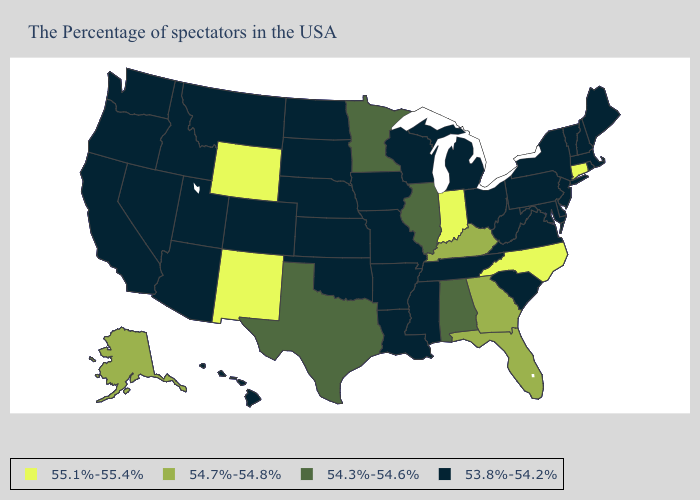What is the highest value in the USA?
Quick response, please. 55.1%-55.4%. What is the lowest value in the USA?
Answer briefly. 53.8%-54.2%. Name the states that have a value in the range 55.1%-55.4%?
Quick response, please. Connecticut, North Carolina, Indiana, Wyoming, New Mexico. Among the states that border Missouri , which have the highest value?
Write a very short answer. Kentucky. What is the value of Alabama?
Keep it brief. 54.3%-54.6%. Which states hav the highest value in the MidWest?
Answer briefly. Indiana. Name the states that have a value in the range 53.8%-54.2%?
Concise answer only. Maine, Massachusetts, Rhode Island, New Hampshire, Vermont, New York, New Jersey, Delaware, Maryland, Pennsylvania, Virginia, South Carolina, West Virginia, Ohio, Michigan, Tennessee, Wisconsin, Mississippi, Louisiana, Missouri, Arkansas, Iowa, Kansas, Nebraska, Oklahoma, South Dakota, North Dakota, Colorado, Utah, Montana, Arizona, Idaho, Nevada, California, Washington, Oregon, Hawaii. Does the map have missing data?
Give a very brief answer. No. What is the highest value in the USA?
Short answer required. 55.1%-55.4%. Does Vermont have the same value as Connecticut?
Be succinct. No. Does the first symbol in the legend represent the smallest category?
Keep it brief. No. What is the value of Pennsylvania?
Write a very short answer. 53.8%-54.2%. What is the value of Oregon?
Answer briefly. 53.8%-54.2%. Name the states that have a value in the range 53.8%-54.2%?
Answer briefly. Maine, Massachusetts, Rhode Island, New Hampshire, Vermont, New York, New Jersey, Delaware, Maryland, Pennsylvania, Virginia, South Carolina, West Virginia, Ohio, Michigan, Tennessee, Wisconsin, Mississippi, Louisiana, Missouri, Arkansas, Iowa, Kansas, Nebraska, Oklahoma, South Dakota, North Dakota, Colorado, Utah, Montana, Arizona, Idaho, Nevada, California, Washington, Oregon, Hawaii. 